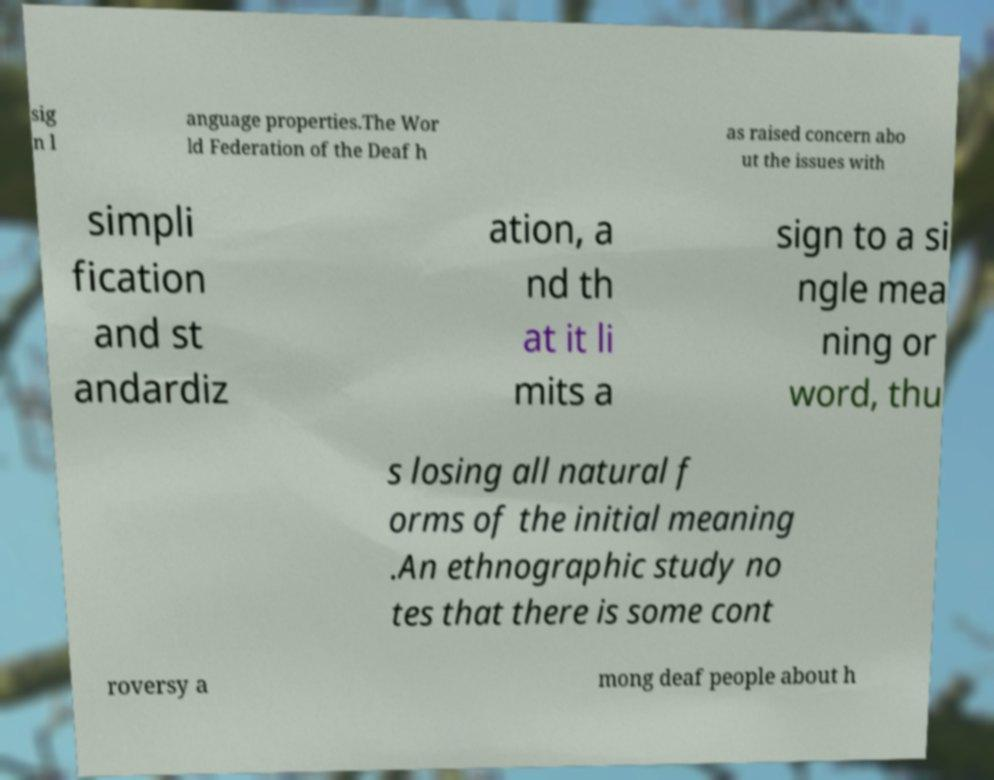For documentation purposes, I need the text within this image transcribed. Could you provide that? sig n l anguage properties.The Wor ld Federation of the Deaf h as raised concern abo ut the issues with simpli fication and st andardiz ation, a nd th at it li mits a sign to a si ngle mea ning or word, thu s losing all natural f orms of the initial meaning .An ethnographic study no tes that there is some cont roversy a mong deaf people about h 